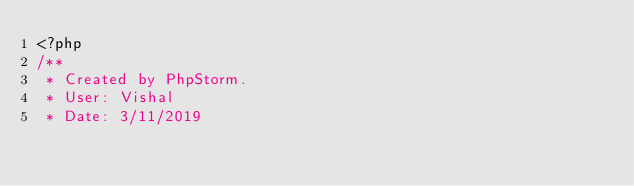<code> <loc_0><loc_0><loc_500><loc_500><_PHP_><?php
/**
 * Created by PhpStorm.
 * User: Vishal
 * Date: 3/11/2019</code> 